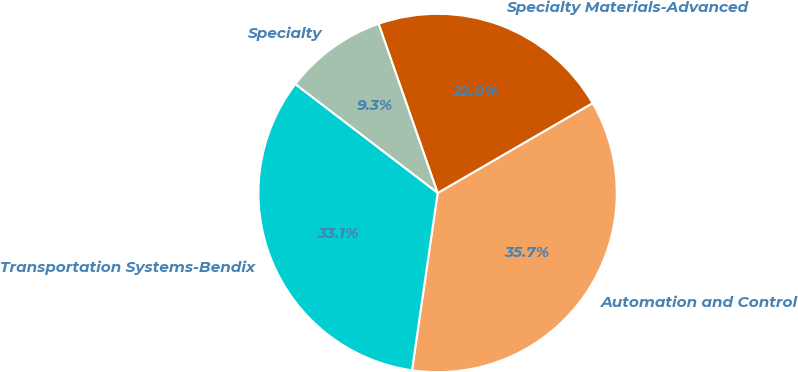Convert chart. <chart><loc_0><loc_0><loc_500><loc_500><pie_chart><fcel>Automation and Control<fcel>Specialty Materials-Advanced<fcel>Specialty<fcel>Transportation Systems-Bendix<nl><fcel>35.65%<fcel>21.98%<fcel>9.27%<fcel>33.1%<nl></chart> 